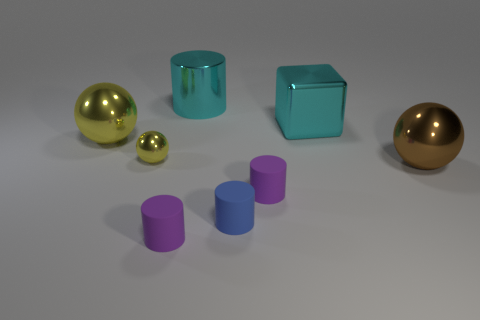There is a blue cylinder to the left of the brown metallic object; what is its size?
Offer a very short reply. Small. Are there the same number of objects to the left of the big yellow metal ball and small blue metallic objects?
Your response must be concise. Yes. Is there a large purple metal thing of the same shape as the small yellow object?
Provide a succinct answer. No. There is a big thing that is both on the right side of the blue cylinder and behind the tiny ball; what is its shape?
Your response must be concise. Cube. Is the brown thing made of the same material as the cylinder that is behind the brown shiny thing?
Your answer should be very brief. Yes. Are there any tiny cylinders on the left side of the small blue cylinder?
Ensure brevity in your answer.  Yes. How many things are small blue cubes or objects to the left of the brown ball?
Provide a short and direct response. 7. What color is the cylinder that is behind the thing to the right of the large metal block?
Your answer should be very brief. Cyan. What number of other things are there of the same material as the blue cylinder
Offer a very short reply. 2. What number of matte things are brown cylinders or blue things?
Keep it short and to the point. 1. 